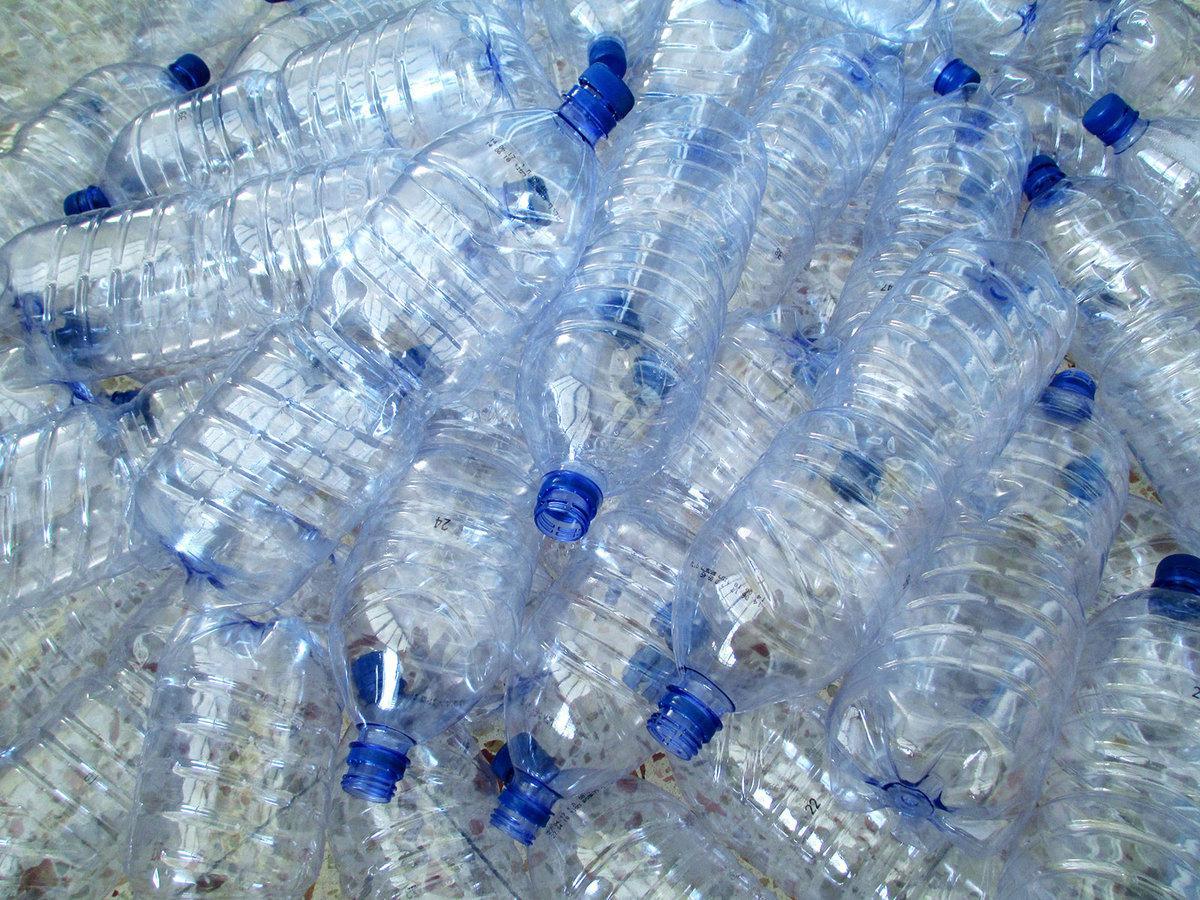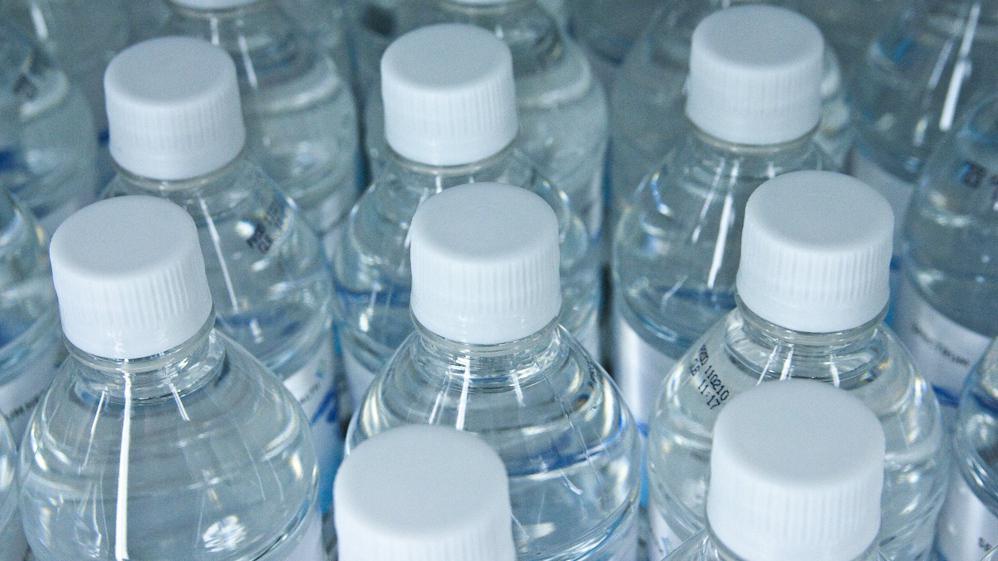The first image is the image on the left, the second image is the image on the right. Assess this claim about the two images: "the bottles in the image on the right have white caps.". Correct or not? Answer yes or no. Yes. The first image is the image on the left, the second image is the image on the right. Examine the images to the left and right. Is the description "The bottles have white caps in at least one of the images." accurate? Answer yes or no. Yes. 